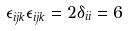Convert formula to latex. <formula><loc_0><loc_0><loc_500><loc_500>\epsilon _ { i j k } \epsilon _ { i j k } = 2 \delta _ { i i } = 6</formula> 